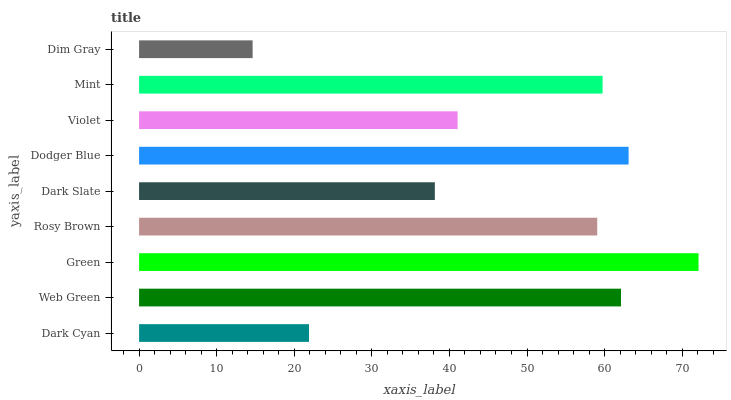Is Dim Gray the minimum?
Answer yes or no. Yes. Is Green the maximum?
Answer yes or no. Yes. Is Web Green the minimum?
Answer yes or no. No. Is Web Green the maximum?
Answer yes or no. No. Is Web Green greater than Dark Cyan?
Answer yes or no. Yes. Is Dark Cyan less than Web Green?
Answer yes or no. Yes. Is Dark Cyan greater than Web Green?
Answer yes or no. No. Is Web Green less than Dark Cyan?
Answer yes or no. No. Is Rosy Brown the high median?
Answer yes or no. Yes. Is Rosy Brown the low median?
Answer yes or no. Yes. Is Dodger Blue the high median?
Answer yes or no. No. Is Dark Cyan the low median?
Answer yes or no. No. 